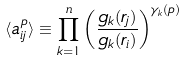<formula> <loc_0><loc_0><loc_500><loc_500>\langle a _ { i j } ^ { p } \rangle \equiv \prod _ { k = 1 } ^ { n } \left ( \frac { g _ { k } ( r _ { j } ) } { g _ { k } ( r _ { i } ) } \right ) ^ { \gamma _ { k } ( p ) }</formula> 